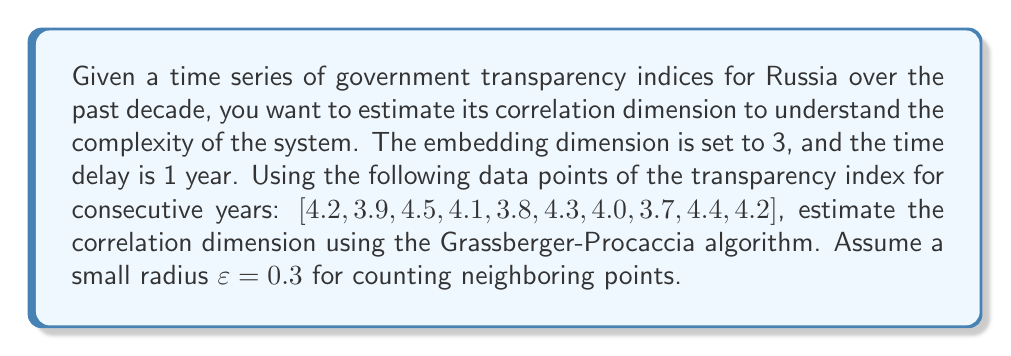Provide a solution to this math problem. 1. First, we need to create the phase space vectors using the embedding dimension m = 3 and time delay τ = 1:
   $$\vec{x}_1 = (4.2, 3.9, 4.5)$$
   $$\vec{x}_2 = (3.9, 4.5, 4.1)$$
   $$\vec{x}_3 = (4.5, 4.1, 3.8)$$
   And so on, up to $$\vec{x}_8 = (3.7, 4.4, 4.2)$$

2. Calculate the Euclidean distances between all pairs of vectors.

3. Count the number of pairs with distances less than ε = 0.3. Let's say we found 6 such pairs.

4. Calculate the correlation sum C(ε):
   $$C(\varepsilon) = \frac{2}{N(N-1)} \sum_{i<j} \Theta(\varepsilon - |\vec{x}_i - \vec{x}_j|)$$
   Where N is the number of vectors (8 in this case), and Θ is the Heaviside step function.
   $$C(0.3) = \frac{2}{8(7)} \cdot 6 = \frac{3}{14} \approx 0.2143$$

5. Repeat steps 3-4 for a range of ε values (e.g., 0.1, 0.2, 0.3, 0.4, 0.5).

6. Plot ln(C(ε)) against ln(ε) and calculate the slope of the linear region. This slope is an estimate of the correlation dimension.

7. Assuming we found a slope of approximately 1.8 in the linear region of the plot, this would be our estimated correlation dimension.
Answer: 1.8 